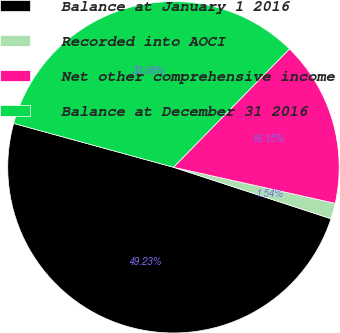Convert chart. <chart><loc_0><loc_0><loc_500><loc_500><pie_chart><fcel>Balance at January 1 2016<fcel>Recorded into AOCI<fcel>Net other comprehensive income<fcel>Balance at December 31 2016<nl><fcel>49.23%<fcel>1.54%<fcel>16.15%<fcel>33.08%<nl></chart> 